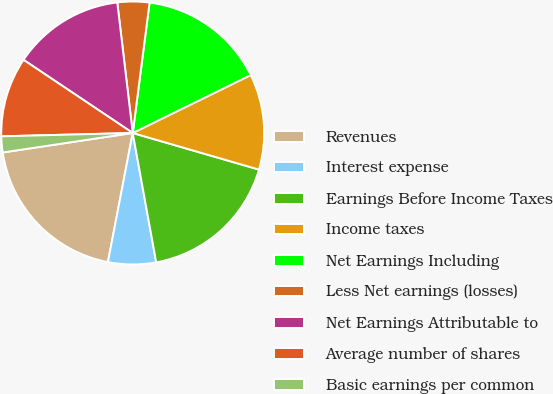Convert chart to OTSL. <chart><loc_0><loc_0><loc_500><loc_500><pie_chart><fcel>Revenues<fcel>Interest expense<fcel>Earnings Before Income Taxes<fcel>Income taxes<fcel>Net Earnings Including<fcel>Less Net earnings (losses)<fcel>Net Earnings Attributable to<fcel>Average number of shares<fcel>Basic earnings per common<nl><fcel>19.61%<fcel>5.88%<fcel>17.65%<fcel>11.76%<fcel>15.69%<fcel>3.92%<fcel>13.73%<fcel>9.8%<fcel>1.96%<nl></chart> 